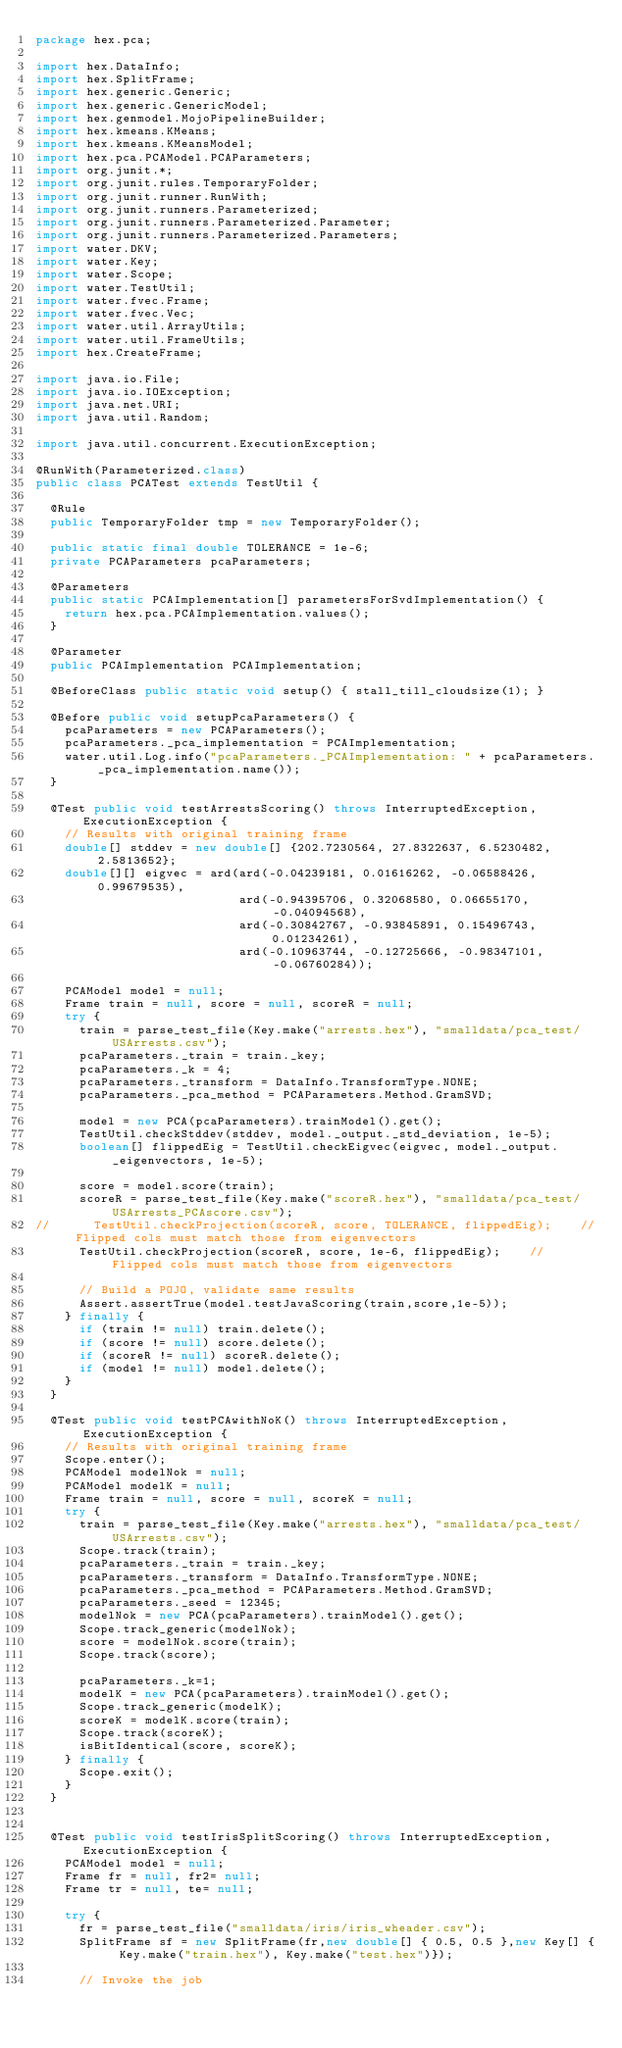<code> <loc_0><loc_0><loc_500><loc_500><_Java_>package hex.pca;

import hex.DataInfo;
import hex.SplitFrame;
import hex.generic.Generic;
import hex.generic.GenericModel;
import hex.genmodel.MojoPipelineBuilder;
import hex.kmeans.KMeans;
import hex.kmeans.KMeansModel;
import hex.pca.PCAModel.PCAParameters;
import org.junit.*;
import org.junit.rules.TemporaryFolder;
import org.junit.runner.RunWith;
import org.junit.runners.Parameterized;
import org.junit.runners.Parameterized.Parameter;
import org.junit.runners.Parameterized.Parameters;
import water.DKV;
import water.Key;
import water.Scope;
import water.TestUtil;
import water.fvec.Frame;
import water.fvec.Vec;
import water.util.ArrayUtils;
import water.util.FrameUtils;
import hex.CreateFrame;

import java.io.File;
import java.io.IOException;
import java.net.URI;
import java.util.Random;

import java.util.concurrent.ExecutionException;

@RunWith(Parameterized.class)
public class PCATest extends TestUtil {
  
  @Rule
  public TemporaryFolder tmp = new TemporaryFolder();
  
  public static final double TOLERANCE = 1e-6;
  private PCAParameters pcaParameters;

  @Parameters
  public static PCAImplementation[] parametersForSvdImplementation() {
    return hex.pca.PCAImplementation.values();
  }

  @Parameter
  public PCAImplementation PCAImplementation;

  @BeforeClass public static void setup() { stall_till_cloudsize(1); }

  @Before public void setupPcaParameters() {
    pcaParameters = new PCAParameters();
    pcaParameters._pca_implementation = PCAImplementation;
    water.util.Log.info("pcaParameters._PCAImplementation: " + pcaParameters._pca_implementation.name());
  }

  @Test public void testArrestsScoring() throws InterruptedException, ExecutionException {
    // Results with original training frame
    double[] stddev = new double[] {202.7230564, 27.8322637, 6.5230482, 2.5813652};
    double[][] eigvec = ard(ard(-0.04239181, 0.01616262, -0.06588426, 0.99679535),
                            ard(-0.94395706, 0.32068580, 0.06655170, -0.04094568),
                            ard(-0.30842767, -0.93845891, 0.15496743, 0.01234261),
                            ard(-0.10963744, -0.12725666, -0.98347101, -0.06760284));

    PCAModel model = null;
    Frame train = null, score = null, scoreR = null;
    try {
      train = parse_test_file(Key.make("arrests.hex"), "smalldata/pca_test/USArrests.csv");
      pcaParameters._train = train._key;
      pcaParameters._k = 4;
      pcaParameters._transform = DataInfo.TransformType.NONE;
      pcaParameters._pca_method = PCAParameters.Method.GramSVD;

      model = new PCA(pcaParameters).trainModel().get();
      TestUtil.checkStddev(stddev, model._output._std_deviation, 1e-5);
      boolean[] flippedEig = TestUtil.checkEigvec(eigvec, model._output._eigenvectors, 1e-5);

      score = model.score(train);
      scoreR = parse_test_file(Key.make("scoreR.hex"), "smalldata/pca_test/USArrests_PCAscore.csv");
//      TestUtil.checkProjection(scoreR, score, TOLERANCE, flippedEig);    // Flipped cols must match those from eigenvectors
      TestUtil.checkProjection(scoreR, score, 1e-6, flippedEig);    // Flipped cols must match those from eigenvectors

      // Build a POJO, validate same results
      Assert.assertTrue(model.testJavaScoring(train,score,1e-5));
    } finally {
      if (train != null) train.delete();
      if (score != null) score.delete();
      if (scoreR != null) scoreR.delete();
      if (model != null) model.delete();
    }
  }

  @Test public void testPCAwithNoK() throws InterruptedException, ExecutionException {
    // Results with original training frame
    Scope.enter();
    PCAModel modelNok = null;
    PCAModel modelK = null;
    Frame train = null, score = null, scoreK = null;
    try {
      train = parse_test_file(Key.make("arrests.hex"), "smalldata/pca_test/USArrests.csv");
      Scope.track(train);
      pcaParameters._train = train._key;
      pcaParameters._transform = DataInfo.TransformType.NONE;
      pcaParameters._pca_method = PCAParameters.Method.GramSVD;
      pcaParameters._seed = 12345;
      modelNok = new PCA(pcaParameters).trainModel().get();
      Scope.track_generic(modelNok);
      score = modelNok.score(train);
      Scope.track(score);
      
      pcaParameters._k=1;
      modelK = new PCA(pcaParameters).trainModel().get();
      Scope.track_generic(modelK);
      scoreK = modelK.score(train);
      Scope.track(scoreK);
      isBitIdentical(score, scoreK);
    } finally {
      Scope.exit();
    }
  }


  @Test public void testIrisSplitScoring() throws InterruptedException, ExecutionException {
    PCAModel model = null;
    Frame fr = null, fr2= null;
    Frame tr = null, te= null;

    try {
      fr = parse_test_file("smalldata/iris/iris_wheader.csv");
      SplitFrame sf = new SplitFrame(fr,new double[] { 0.5, 0.5 },new Key[] { Key.make("train.hex"), Key.make("test.hex")});

      // Invoke the job</code> 